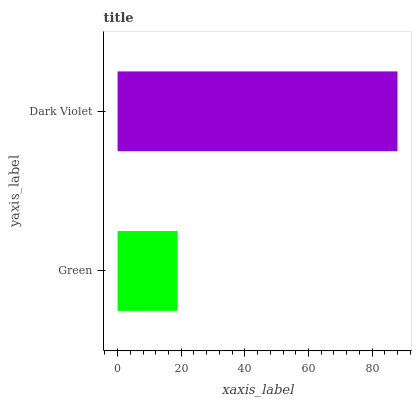Is Green the minimum?
Answer yes or no. Yes. Is Dark Violet the maximum?
Answer yes or no. Yes. Is Dark Violet the minimum?
Answer yes or no. No. Is Dark Violet greater than Green?
Answer yes or no. Yes. Is Green less than Dark Violet?
Answer yes or no. Yes. Is Green greater than Dark Violet?
Answer yes or no. No. Is Dark Violet less than Green?
Answer yes or no. No. Is Dark Violet the high median?
Answer yes or no. Yes. Is Green the low median?
Answer yes or no. Yes. Is Green the high median?
Answer yes or no. No. Is Dark Violet the low median?
Answer yes or no. No. 